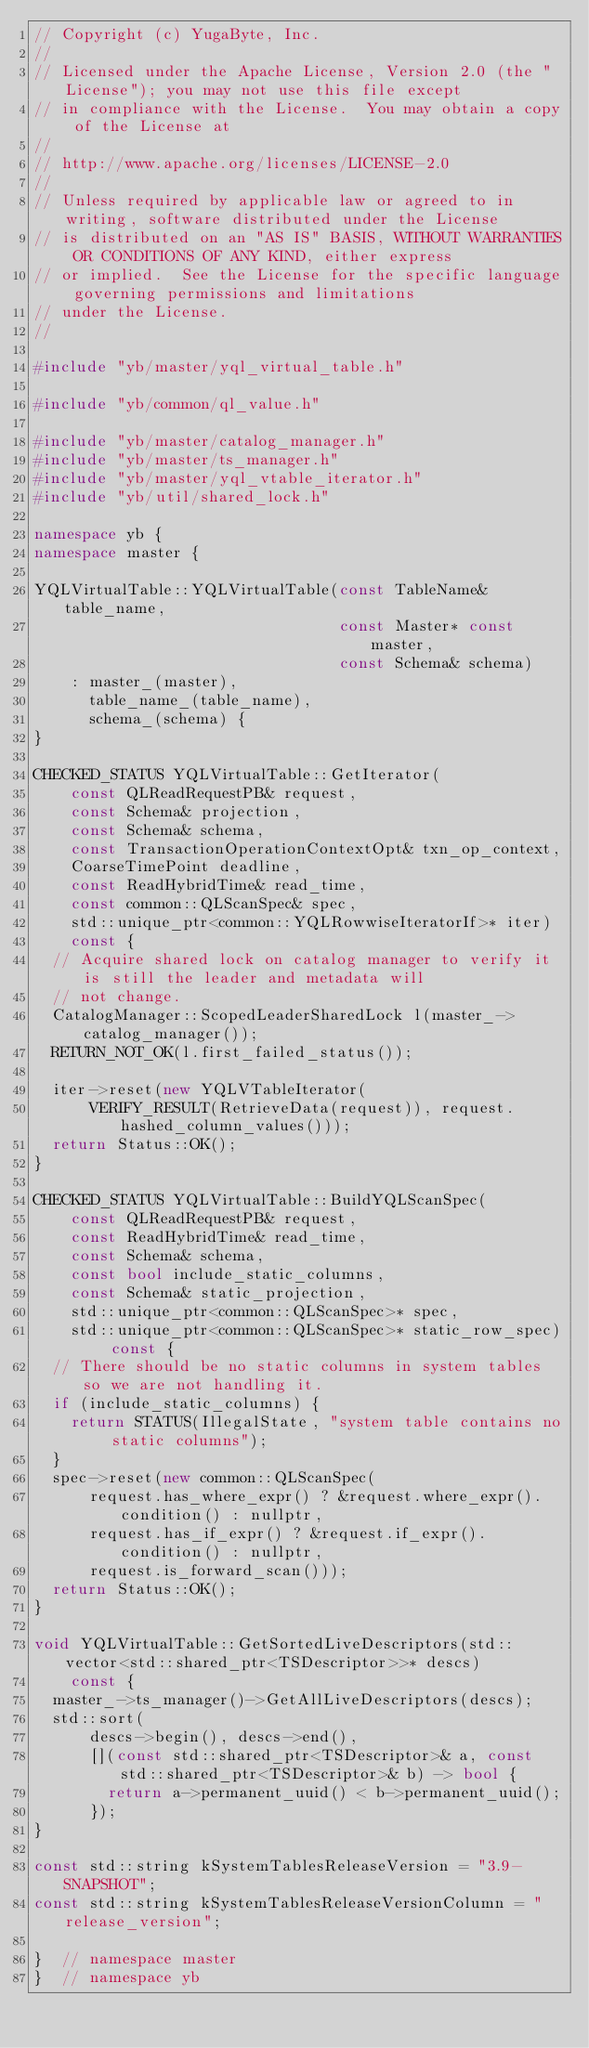<code> <loc_0><loc_0><loc_500><loc_500><_C++_>// Copyright (c) YugaByte, Inc.
//
// Licensed under the Apache License, Version 2.0 (the "License"); you may not use this file except
// in compliance with the License.  You may obtain a copy of the License at
//
// http://www.apache.org/licenses/LICENSE-2.0
//
// Unless required by applicable law or agreed to in writing, software distributed under the License
// is distributed on an "AS IS" BASIS, WITHOUT WARRANTIES OR CONDITIONS OF ANY KIND, either express
// or implied.  See the License for the specific language governing permissions and limitations
// under the License.
//

#include "yb/master/yql_virtual_table.h"

#include "yb/common/ql_value.h"

#include "yb/master/catalog_manager.h"
#include "yb/master/ts_manager.h"
#include "yb/master/yql_vtable_iterator.h"
#include "yb/util/shared_lock.h"

namespace yb {
namespace master {

YQLVirtualTable::YQLVirtualTable(const TableName& table_name,
                                 const Master* const master,
                                 const Schema& schema)
    : master_(master),
      table_name_(table_name),
      schema_(schema) {
}

CHECKED_STATUS YQLVirtualTable::GetIterator(
    const QLReadRequestPB& request,
    const Schema& projection,
    const Schema& schema,
    const TransactionOperationContextOpt& txn_op_context,
    CoarseTimePoint deadline,
    const ReadHybridTime& read_time,
    const common::QLScanSpec& spec,
    std::unique_ptr<common::YQLRowwiseIteratorIf>* iter)
    const {
  // Acquire shared lock on catalog manager to verify it is still the leader and metadata will
  // not change.
  CatalogManager::ScopedLeaderSharedLock l(master_->catalog_manager());
  RETURN_NOT_OK(l.first_failed_status());

  iter->reset(new YQLVTableIterator(
      VERIFY_RESULT(RetrieveData(request)), request.hashed_column_values()));
  return Status::OK();
}

CHECKED_STATUS YQLVirtualTable::BuildYQLScanSpec(
    const QLReadRequestPB& request,
    const ReadHybridTime& read_time,
    const Schema& schema,
    const bool include_static_columns,
    const Schema& static_projection,
    std::unique_ptr<common::QLScanSpec>* spec,
    std::unique_ptr<common::QLScanSpec>* static_row_spec) const {
  // There should be no static columns in system tables so we are not handling it.
  if (include_static_columns) {
    return STATUS(IllegalState, "system table contains no static columns");
  }
  spec->reset(new common::QLScanSpec(
      request.has_where_expr() ? &request.where_expr().condition() : nullptr,
      request.has_if_expr() ? &request.if_expr().condition() : nullptr,
      request.is_forward_scan()));
  return Status::OK();
}

void YQLVirtualTable::GetSortedLiveDescriptors(std::vector<std::shared_ptr<TSDescriptor>>* descs)
    const {
  master_->ts_manager()->GetAllLiveDescriptors(descs);
  std::sort(
      descs->begin(), descs->end(),
      [](const std::shared_ptr<TSDescriptor>& a, const std::shared_ptr<TSDescriptor>& b) -> bool {
        return a->permanent_uuid() < b->permanent_uuid();
      });
}

const std::string kSystemTablesReleaseVersion = "3.9-SNAPSHOT";
const std::string kSystemTablesReleaseVersionColumn = "release_version";

}  // namespace master
}  // namespace yb
</code> 